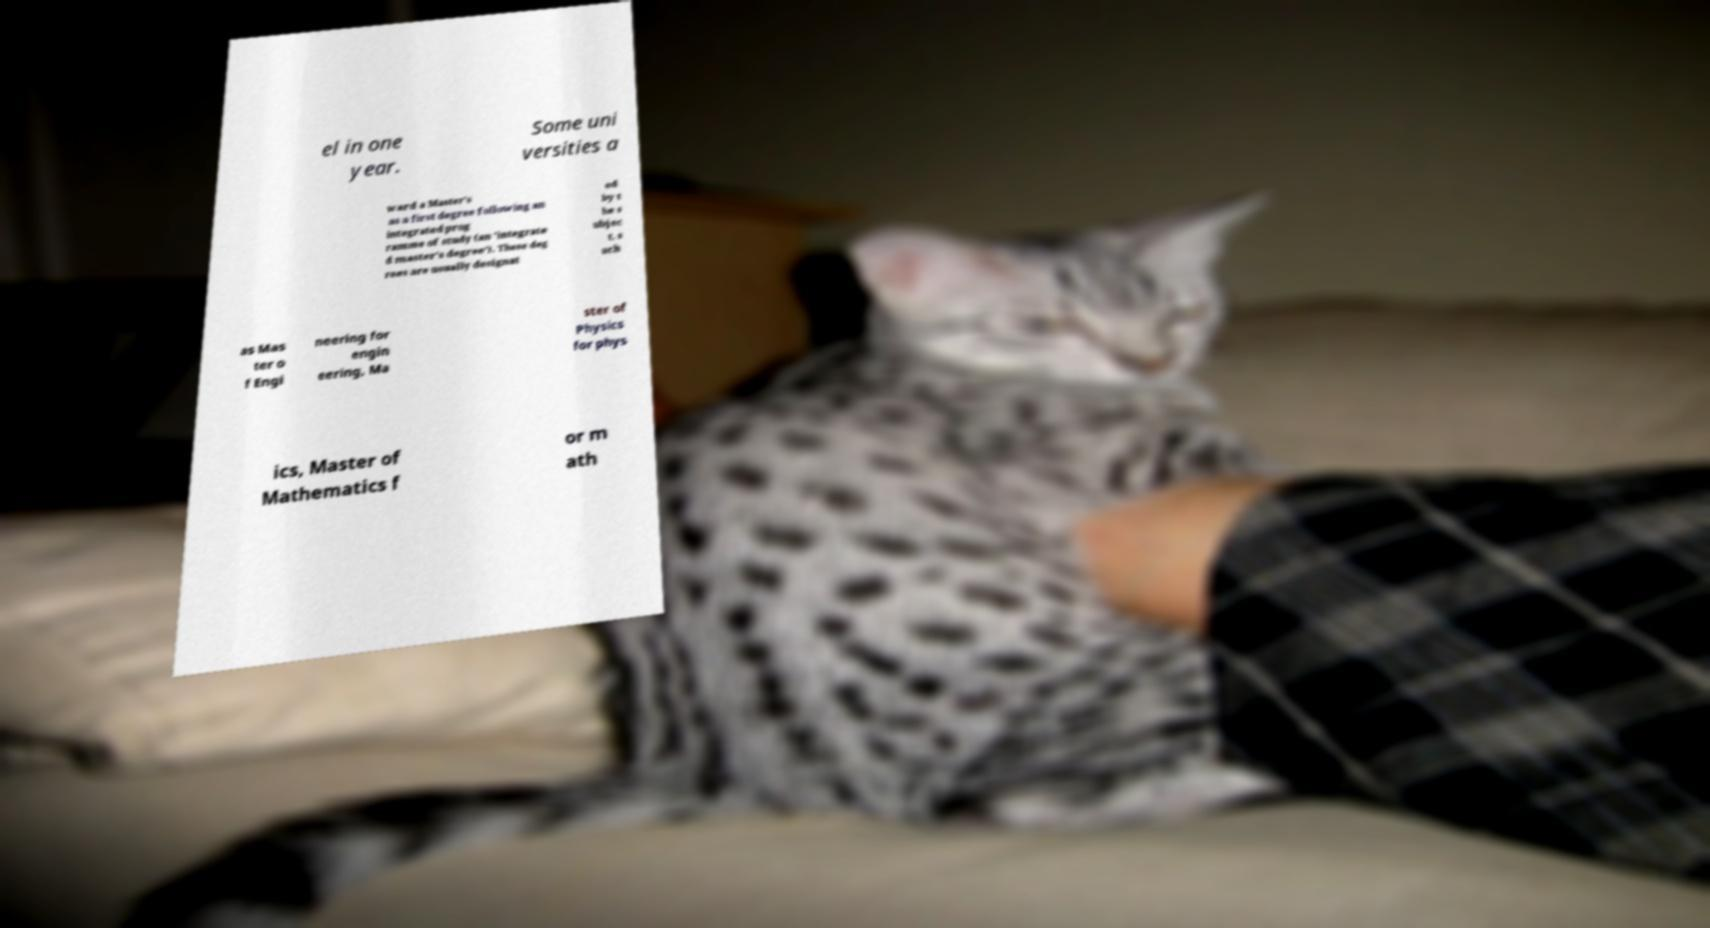Could you assist in decoding the text presented in this image and type it out clearly? el in one year. Some uni versities a ward a Master's as a first degree following an integrated prog ramme of study (an 'integrate d master's degree'). These deg rees are usually designat ed by t he s ubjec t, s uch as Mas ter o f Engi neering for engin eering, Ma ster of Physics for phys ics, Master of Mathematics f or m ath 